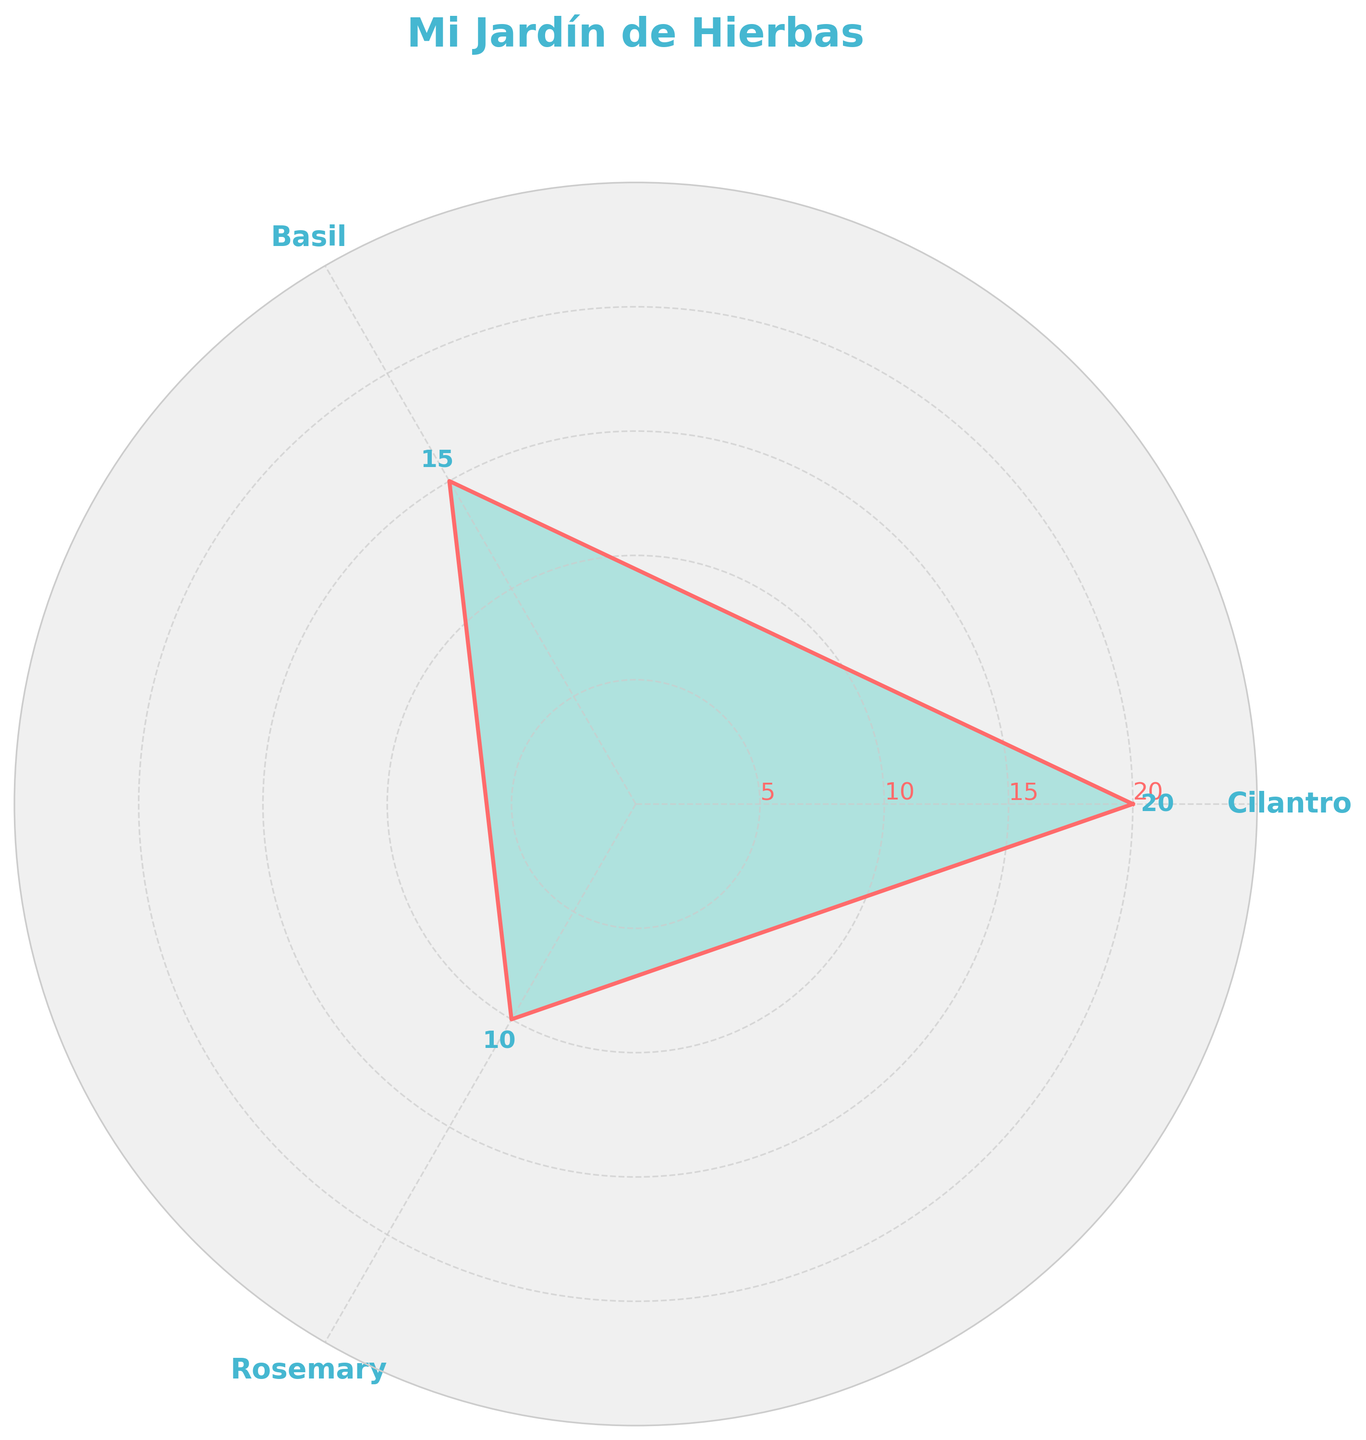What is the title of the chart? The chart's title is displayed at the top in large, bold text.
Answer: Mi Jardín de Hierbas What herb has the highest quantity? By looking at the herb represented with the longest segment extending outwards on the chart, we can determine that Cilantro has the highest quantity.
Answer: Cilantro What is the range of quantities for the herbs? The range is the difference between the highest and lowest quantities. Cilantro has the highest quantity at 20 and Rosemary the lowest at 10. Thus, the range is 20 - 10.
Answer: 10 Which herb has the smallest quantity, and by how much is it smaller than the highest quantity? Rosemary is shown with the smallest segment. The quantity of Rosemary is 10, whereas Cilantro has the highest quantity at 20. The difference is 20 - 10.
Answer: Rosemary, 10 How many tick labels are shown on the y-axis? The y-axis labels are displayed in the form of concentric circles with values at regular intervals. By counting these labels, we find there are four labels: 5, 10, 15, and 20.
Answer: 4 What's the average quantity of the herbs in the chart? To find the average, sum the quantities of all herbs and divide by the number of herbs. (20 + 15 + 10) / 3 = 45 / 3.
Answer: 15 What is the herb with the second highest quantity? The middle-length segment represents the herb with the second highest quantity. Basil's quantity is 15, placing it second after Cilantro.
Answer: Basil What are the color combinations used in the chart? The plot lines are drawn in one color, while the filling color is another. Additionally, the labels and ticks are in different colors. Specifically, the plot's line is red, the area fill is turquoise, and the text labels and ticks are blue.
Answer: Red, turquoise, and blue Which quadrant has the highest concentration of herbs? By visual inspection, the quadrant between 0 to 2π/3 radians has the highest concentration, displaying Cilantro's segment.
Answer: 0 to 2π/3 radians Which herb would you need to plant the most to equal the quantity of Cilantro? Cilantro's quantity is 20. Assuming you boost other herbs to match Cilantro's quantity, for Basil, you would need 20 - 15, thus 5 more plants, and for Rosemary, you would need 20 - 10, thus 10 more plants. Therefore, more Rosemary is needed.
Answer: Rosemary 